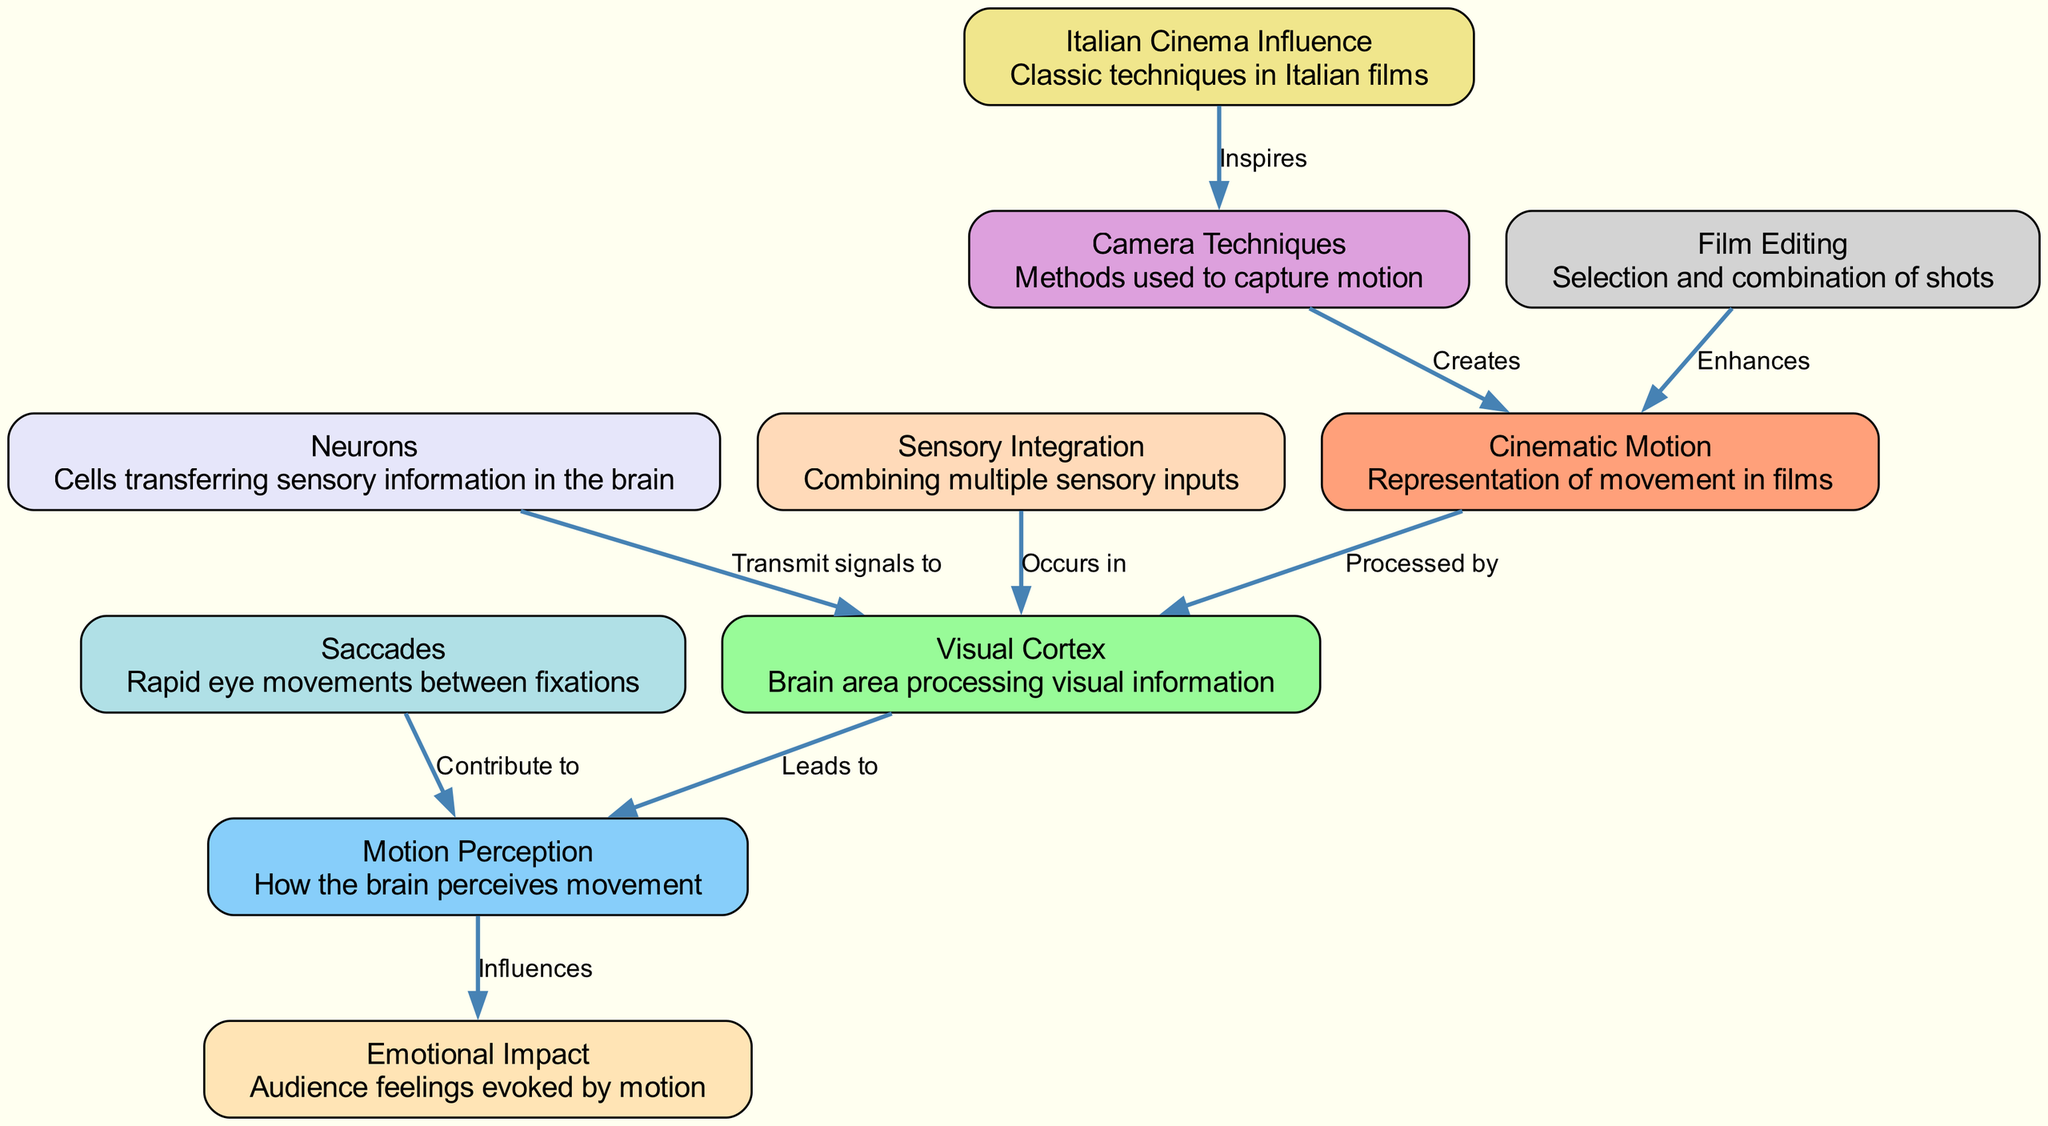What is the total number of nodes in the diagram? The diagram lists 10 nodes, each representing a specific concept related to human motion perception in films. By counting each named node from the provided data, we arrive at a total of 10.
Answer: 10 Which node describes the brain area processing visual information? Among the nodes, "Visual Cortex" specifically refers to the brain area that processes visual information. Identifying the corresponding node by its label leads directly to the answer.
Answer: Visual Cortex What do "Neurons" transmit signals to? The edge connecting "Neurons" to "Visual Cortex" indicates that neurons transmit signals to the visual cortex. This is derived from the labeled relationship in the diagram.
Answer: Visual Cortex Which node contributes to motion perception through eye movements? The node "Saccades" refers to rapid eye movements and indicates its contribution to motion perception. By following the labeled connection from "Saccades" to "Motion Perception", we can conclude this relationship.
Answer: Saccades How is motion perception influenced according to the diagram? The diagram shows that "Motion Perception" influences "Emotional Impact" as indicated by the directed edge labeled "Influences" between the two nodes. This demonstrates how motion perception relates to emotional responses.
Answer: Emotional Impact What type of techniques inspire the camera techniques used in films? The edge from "Italian Cinema Influence" to "Camera Techniques" indicates that traditional Italian film techniques inspire the methods used to capture motion in films. Hence, the answer directly arises from this relationship.
Answer: Italian Cinema Influence Which process occurs in the visual cortex combining multiple sensory inputs? The node "Sensory Integration" is connected to "Visual Cortex" with a labeled edge stating "Occurs in," showing that sensory integration takes place there. This allows us to identify the correct answer.
Answer: Sensory Integration How does film editing relate to cinematic motion? The relationship is depicted by the edge from "Film Editing" to "Cinematic Motion," indicating that film editing enhances cinematic motion, as specified by the labeled connection between these two nodes.
Answer: Enhances What is created by camera techniques according to the diagram? The edge marked "Creates" connecting "Camera Techniques" to "Cinematic Motion" illustrates that camera techniques directly create cinematic motion. This is a straightforward interpretation of the linked nodes.
Answer: Cinematic Motion 